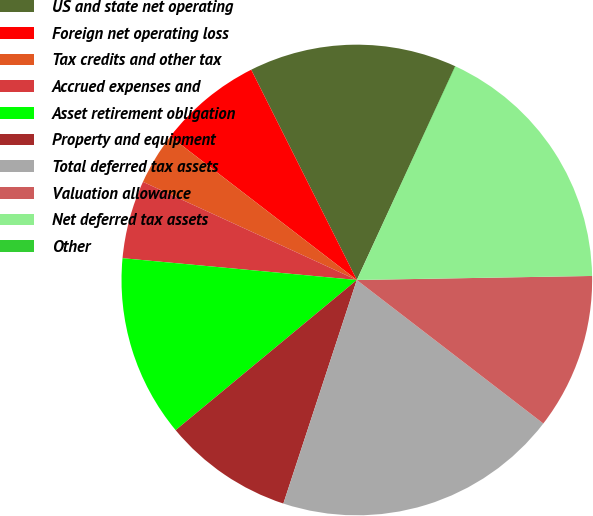<chart> <loc_0><loc_0><loc_500><loc_500><pie_chart><fcel>US and state net operating<fcel>Foreign net operating loss<fcel>Tax credits and other tax<fcel>Accrued expenses and<fcel>Asset retirement obligation<fcel>Property and equipment<fcel>Total deferred tax assets<fcel>Valuation allowance<fcel>Net deferred tax assets<fcel>Other<nl><fcel>14.27%<fcel>7.15%<fcel>3.59%<fcel>5.37%<fcel>12.49%<fcel>8.93%<fcel>19.61%<fcel>10.71%<fcel>17.83%<fcel>0.03%<nl></chart> 